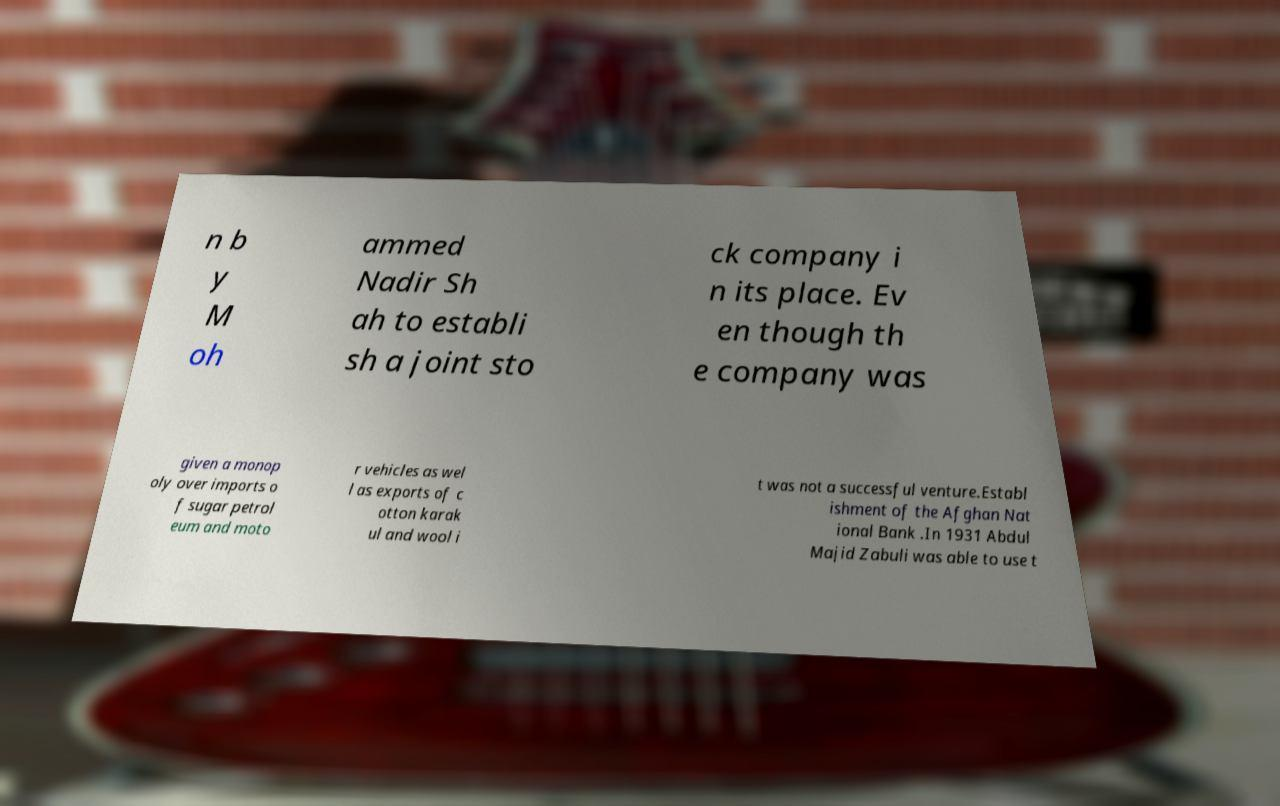Please identify and transcribe the text found in this image. n b y M oh ammed Nadir Sh ah to establi sh a joint sto ck company i n its place. Ev en though th e company was given a monop oly over imports o f sugar petrol eum and moto r vehicles as wel l as exports of c otton karak ul and wool i t was not a successful venture.Establ ishment of the Afghan Nat ional Bank .In 1931 Abdul Majid Zabuli was able to use t 